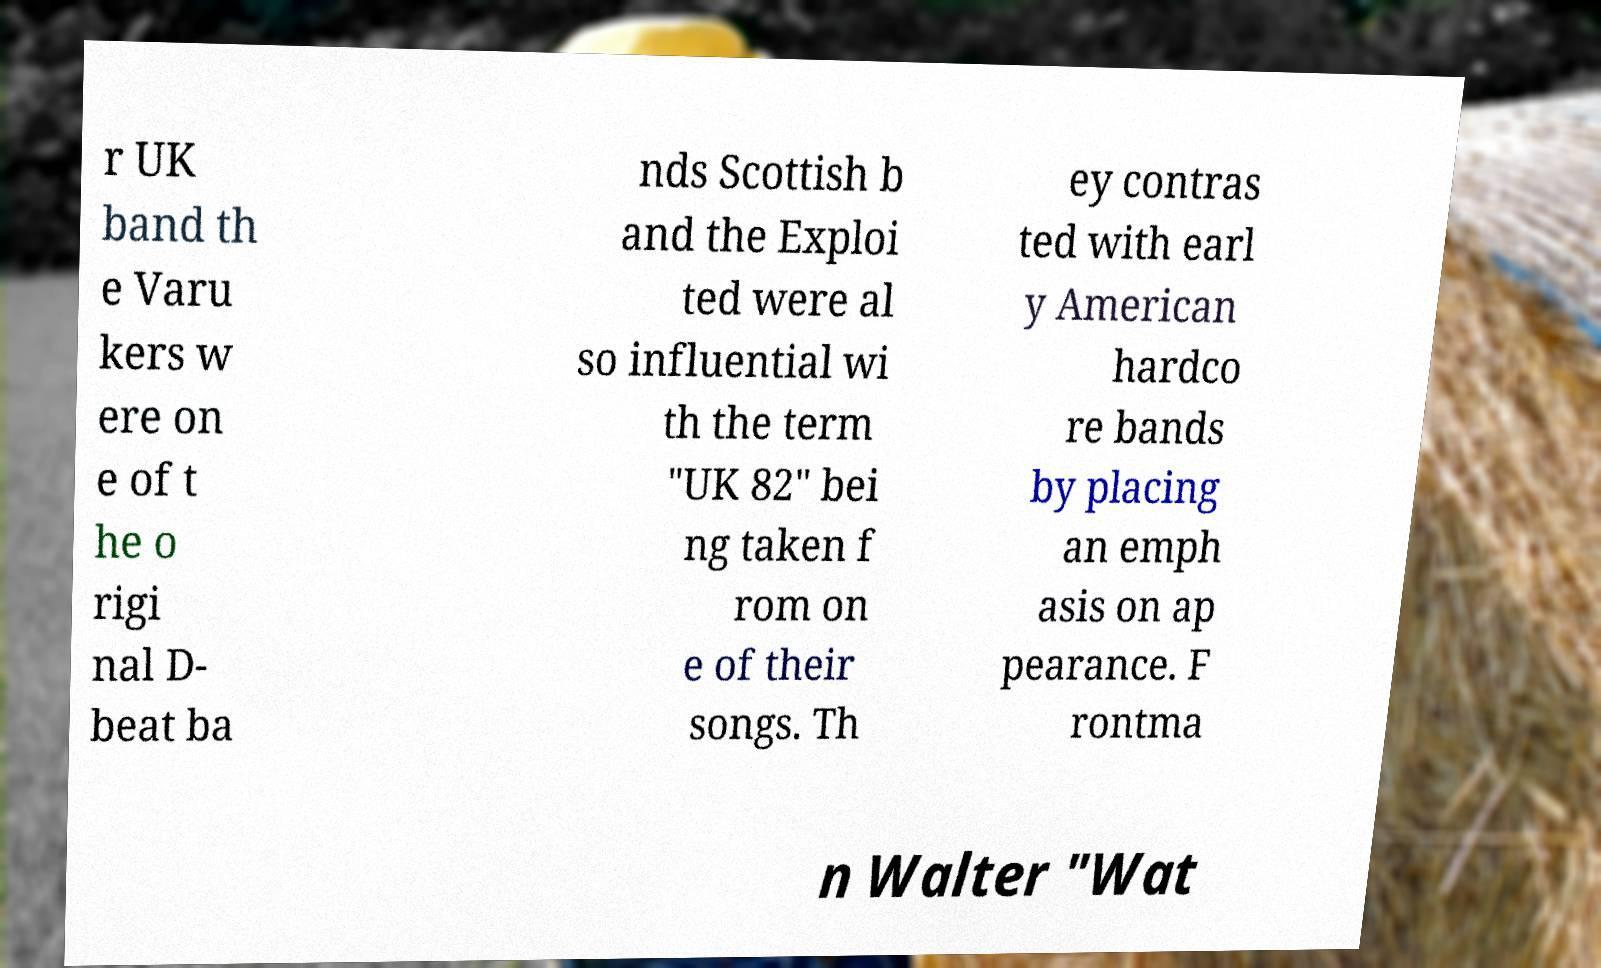For documentation purposes, I need the text within this image transcribed. Could you provide that? r UK band th e Varu kers w ere on e of t he o rigi nal D- beat ba nds Scottish b and the Exploi ted were al so influential wi th the term "UK 82" bei ng taken f rom on e of their songs. Th ey contras ted with earl y American hardco re bands by placing an emph asis on ap pearance. F rontma n Walter "Wat 